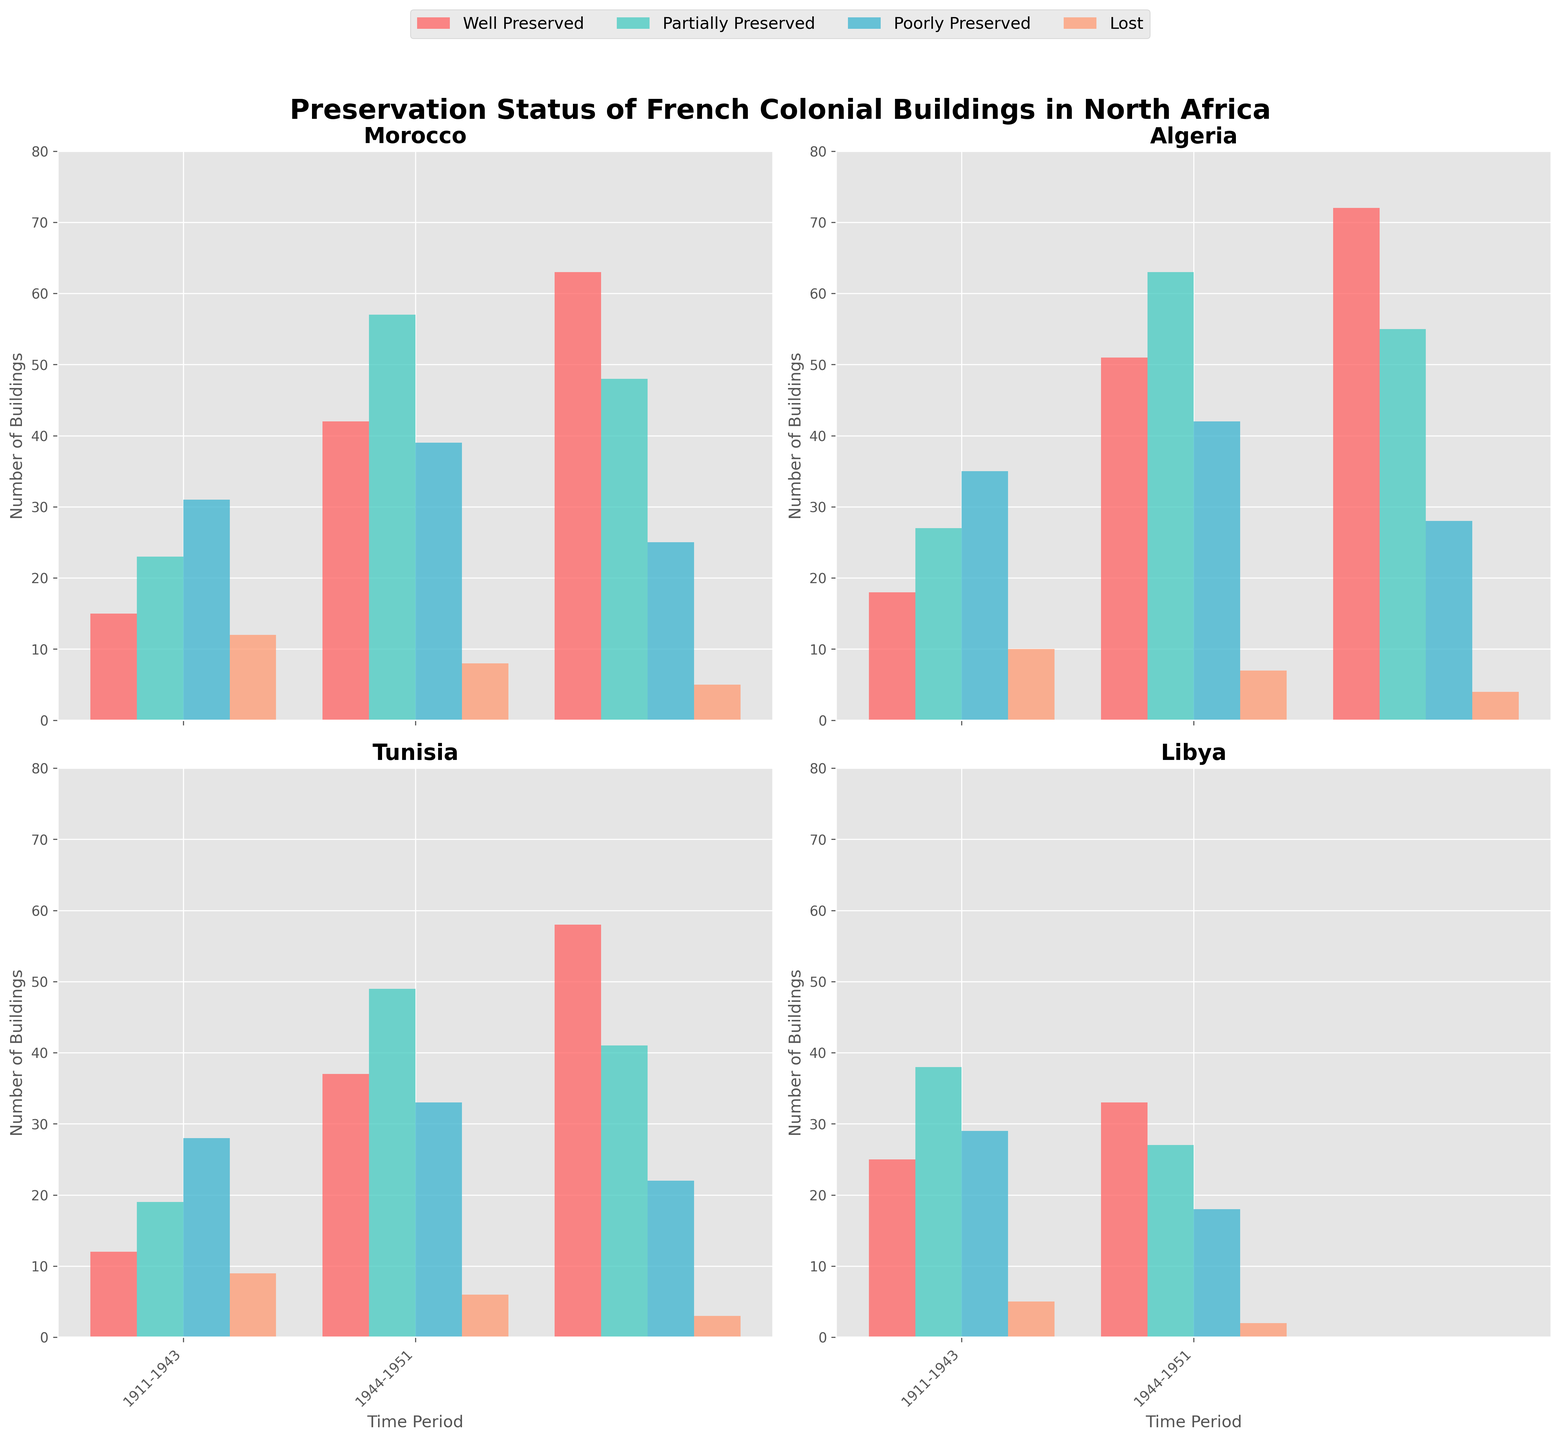What is the title of the chart? The title of the chart is displayed at the top and provides an overview of what the chart is about.
Answer: Preservation Status of French Colonial Buildings in North Africa Which country shows the highest number of well-preserved buildings in the period 1881-1930? By inspecting the bars for the "Well Preserved" category in the 1881-1930 period for each country, Algeria shows the highest number.
Answer: Algeria How many buildings are categorized as "Lost" in Tunisia during the 1830-1880 period? Look at the number for the "Lost" category in the 1830-1880 period subplot for Tunisia; the value is 9.
Answer: 9 Which country has the fewest number of poorly preserved buildings in the 1931-1962 period? By comparing the "Poorly Preserved" category in the 1931-1962 period across countries, Tunisia has the fewest with 22 buildings.
Answer: Tunisia What is the total number of well-preserved buildings in Morocco across all time periods? Sum up the "Well Preserved" numbers for Morocco from 1830-1880, 1881-1930, and 1931-1962: 15 + 42 + 63 = 120.
Answer: 120 Which period shows an increase in partially preserved buildings in Libya from one to the next? In Libya, from 1911-1943 to 1944-1951, the number of partially preserved buildings decreases from 38 to 27. Thus, no period shows an increase.
Answer: No increase Compare the total number of poorly preserved buildings in Algeria and Tunisia in the 1830-1880 period. Which country has more? By comparing, Algeria has 35 and Tunisia has 28 poorly preserved buildings in the 1830-1880 period. Thus, Algeria has more.
Answer: Algeria How does the number of well-preserved buildings in Algeria change from 1881-1930 to 1931-1962? Comparing the "Well Preserved" category numbers for Algeria between the two periods, it increases from 51 to 72.
Answer: It increases What is the average number of lost buildings in Morocco across all periods? Sum up the "Lost" numbers for Morocco: 12 + 8 + 5 = 25, and divide by 3 periods: 25/3 ≈ 8.33.
Answer: Approximately 8.33 Which country shows the highest improvement in the preservation status from poorly preserved to well-preserved between 1830-1880 and 1931-1962? Calculate the difference for each country: Morocco (25 vs 48), Algeria (28 vs 55), Tunisia (22 vs 41), and Libya (doesn't apply). Algeria shows the highest improvement (72-35=37).
Answer: Algeria 